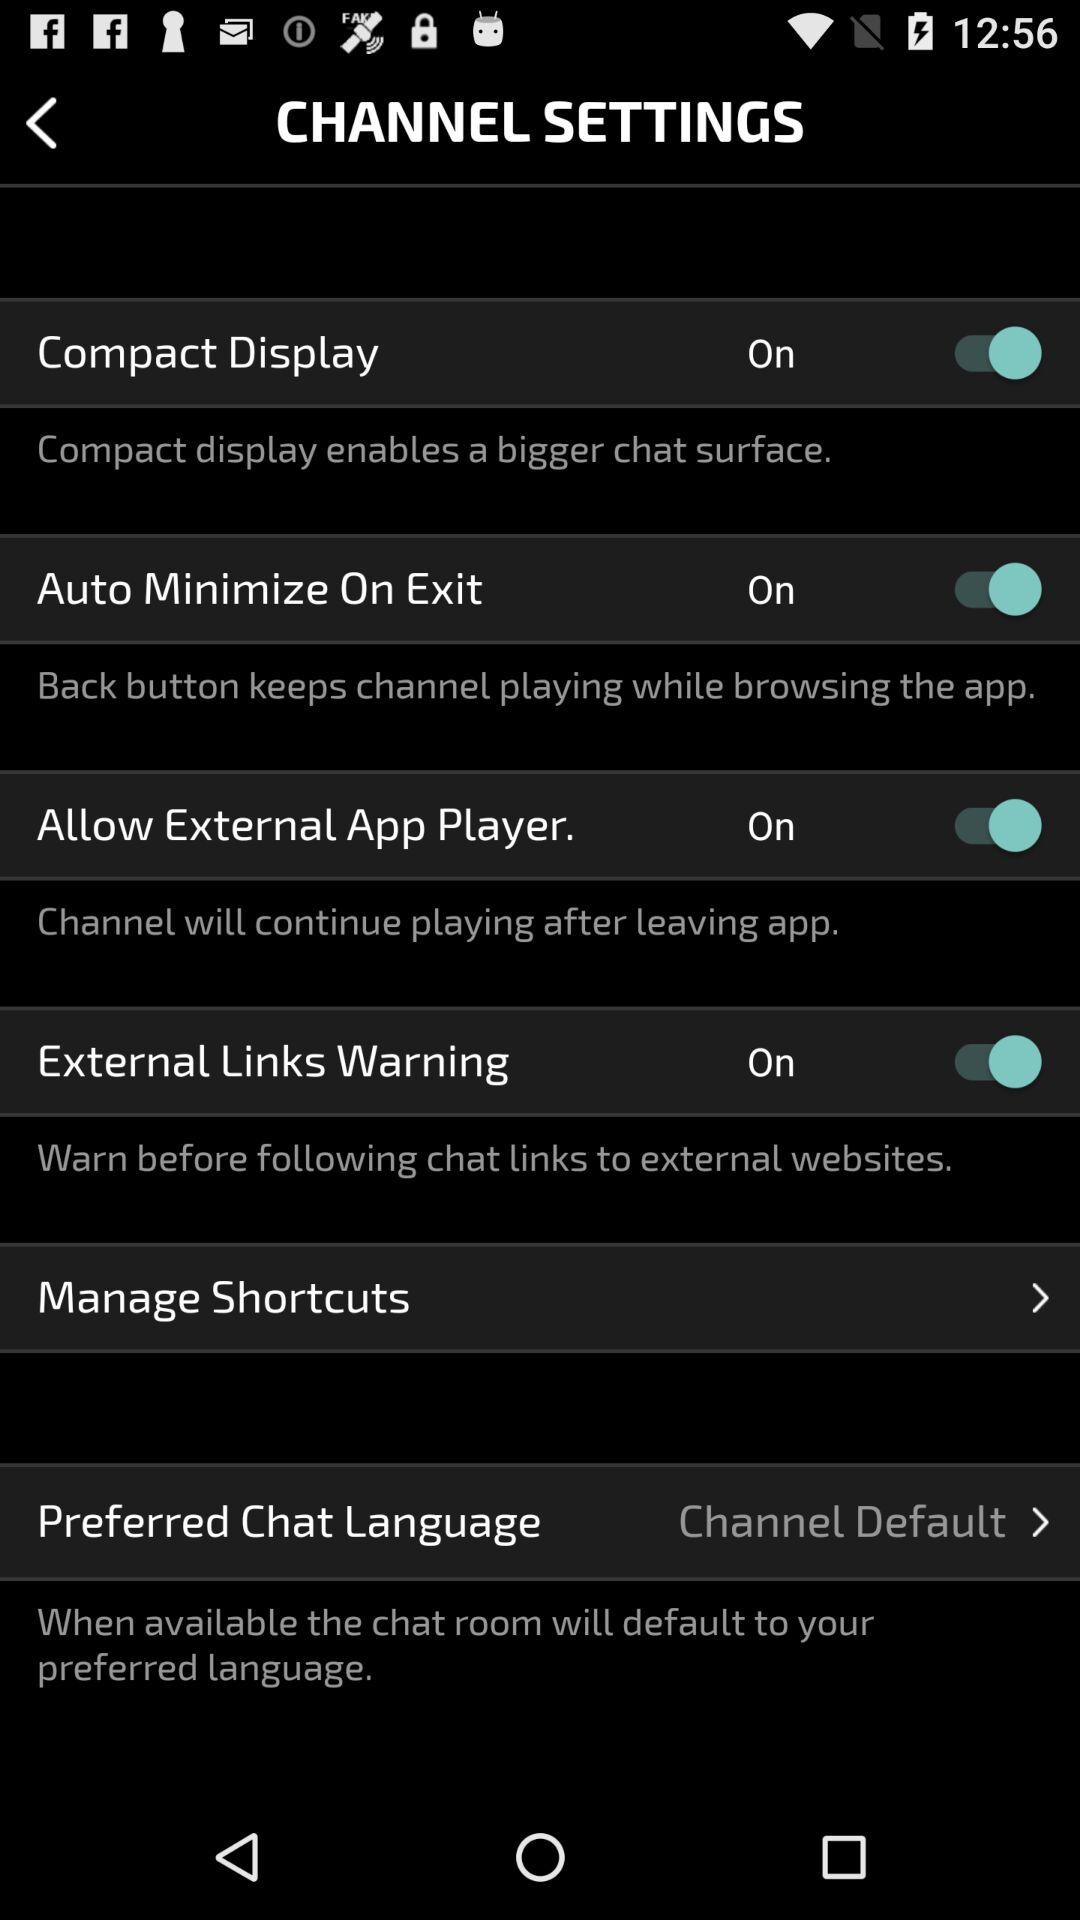What are the available setting options? The available settings are "Compact Display", "Auto Minimize On Exit", "Allow External App Player.", "External Links Warning", "Manage Shortcuts" and "Preferred Chat Language". 